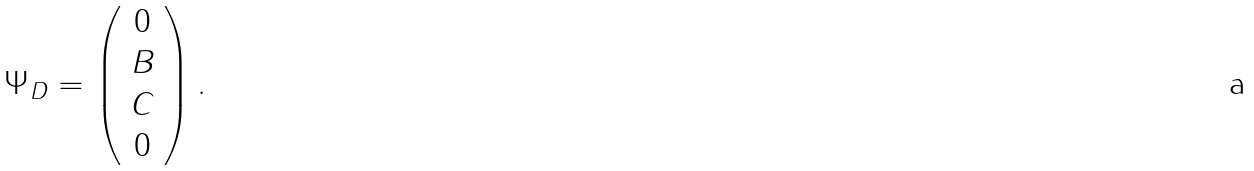<formula> <loc_0><loc_0><loc_500><loc_500>\Psi _ { D } = \left ( \begin{array} { c } { 0 } \\ { B } \\ { C } \\ { 0 } \end{array} \right ) .</formula> 